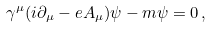Convert formula to latex. <formula><loc_0><loc_0><loc_500><loc_500>\gamma ^ { \mu } ( i \partial _ { \mu } - e A _ { \mu } ) \psi - m \psi = 0 \, ,</formula> 